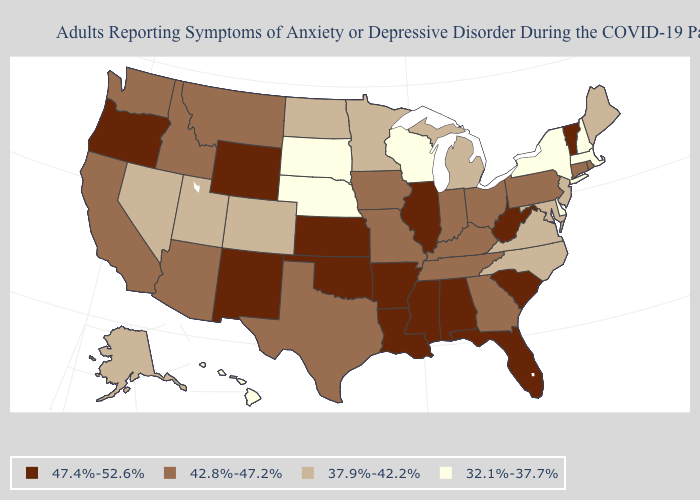What is the highest value in states that border Maine?
Keep it brief. 32.1%-37.7%. What is the highest value in the West ?
Keep it brief. 47.4%-52.6%. What is the value of New Mexico?
Quick response, please. 47.4%-52.6%. Is the legend a continuous bar?
Keep it brief. No. What is the highest value in states that border Mississippi?
Quick response, please. 47.4%-52.6%. What is the lowest value in the USA?
Be succinct. 32.1%-37.7%. Name the states that have a value in the range 42.8%-47.2%?
Be succinct. Arizona, California, Connecticut, Georgia, Idaho, Indiana, Iowa, Kentucky, Missouri, Montana, Ohio, Pennsylvania, Rhode Island, Tennessee, Texas, Washington. Name the states that have a value in the range 47.4%-52.6%?
Concise answer only. Alabama, Arkansas, Florida, Illinois, Kansas, Louisiana, Mississippi, New Mexico, Oklahoma, Oregon, South Carolina, Vermont, West Virginia, Wyoming. Name the states that have a value in the range 47.4%-52.6%?
Keep it brief. Alabama, Arkansas, Florida, Illinois, Kansas, Louisiana, Mississippi, New Mexico, Oklahoma, Oregon, South Carolina, Vermont, West Virginia, Wyoming. Among the states that border Wyoming , which have the lowest value?
Keep it brief. Nebraska, South Dakota. Name the states that have a value in the range 47.4%-52.6%?
Write a very short answer. Alabama, Arkansas, Florida, Illinois, Kansas, Louisiana, Mississippi, New Mexico, Oklahoma, Oregon, South Carolina, Vermont, West Virginia, Wyoming. Among the states that border Vermont , which have the lowest value?
Be succinct. Massachusetts, New Hampshire, New York. Name the states that have a value in the range 37.9%-42.2%?
Quick response, please. Alaska, Colorado, Maine, Maryland, Michigan, Minnesota, Nevada, New Jersey, North Carolina, North Dakota, Utah, Virginia. Among the states that border Oklahoma , does Texas have the highest value?
Concise answer only. No. Name the states that have a value in the range 42.8%-47.2%?
Answer briefly. Arizona, California, Connecticut, Georgia, Idaho, Indiana, Iowa, Kentucky, Missouri, Montana, Ohio, Pennsylvania, Rhode Island, Tennessee, Texas, Washington. 